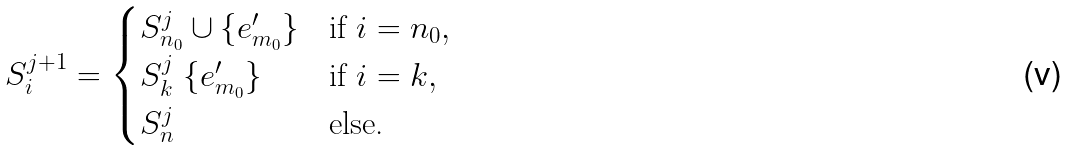Convert formula to latex. <formula><loc_0><loc_0><loc_500><loc_500>S ^ { j + 1 } _ { i } = \begin{cases} S ^ { j } _ { n _ { 0 } } \cup \{ e ^ { \prime } _ { m _ { 0 } } \} & \text {if } i = n _ { 0 } , \\ S ^ { j } _ { k } \ \{ e ^ { \prime } _ { m _ { 0 } } \} & \text {if } i = k , \\ S ^ { j } _ { n } & \text {else.} \end{cases}</formula> 